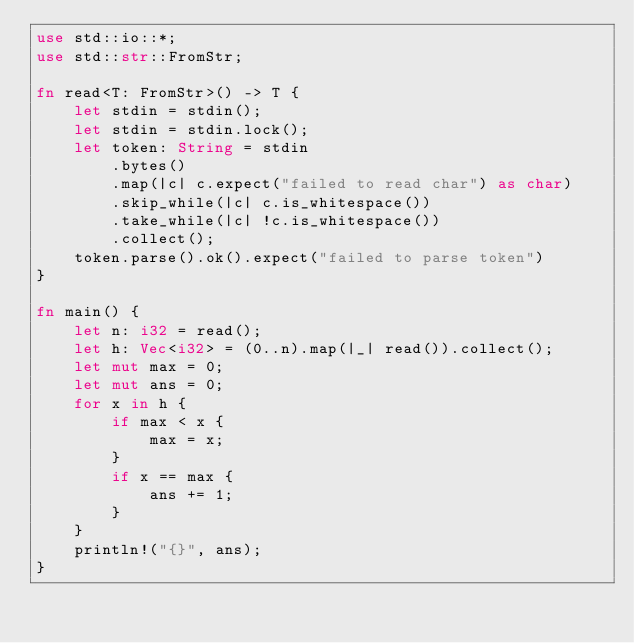Convert code to text. <code><loc_0><loc_0><loc_500><loc_500><_Rust_>use std::io::*;
use std::str::FromStr;

fn read<T: FromStr>() -> T {
    let stdin = stdin();
    let stdin = stdin.lock();
    let token: String = stdin
        .bytes()
        .map(|c| c.expect("failed to read char") as char)
        .skip_while(|c| c.is_whitespace())
        .take_while(|c| !c.is_whitespace())
        .collect();
    token.parse().ok().expect("failed to parse token")
}

fn main() {
    let n: i32 = read();
    let h: Vec<i32> = (0..n).map(|_| read()).collect();
    let mut max = 0;
    let mut ans = 0;
    for x in h {
        if max < x {
            max = x;
        }
        if x == max {
            ans += 1;
        }
    }
    println!("{}", ans);
}
</code> 